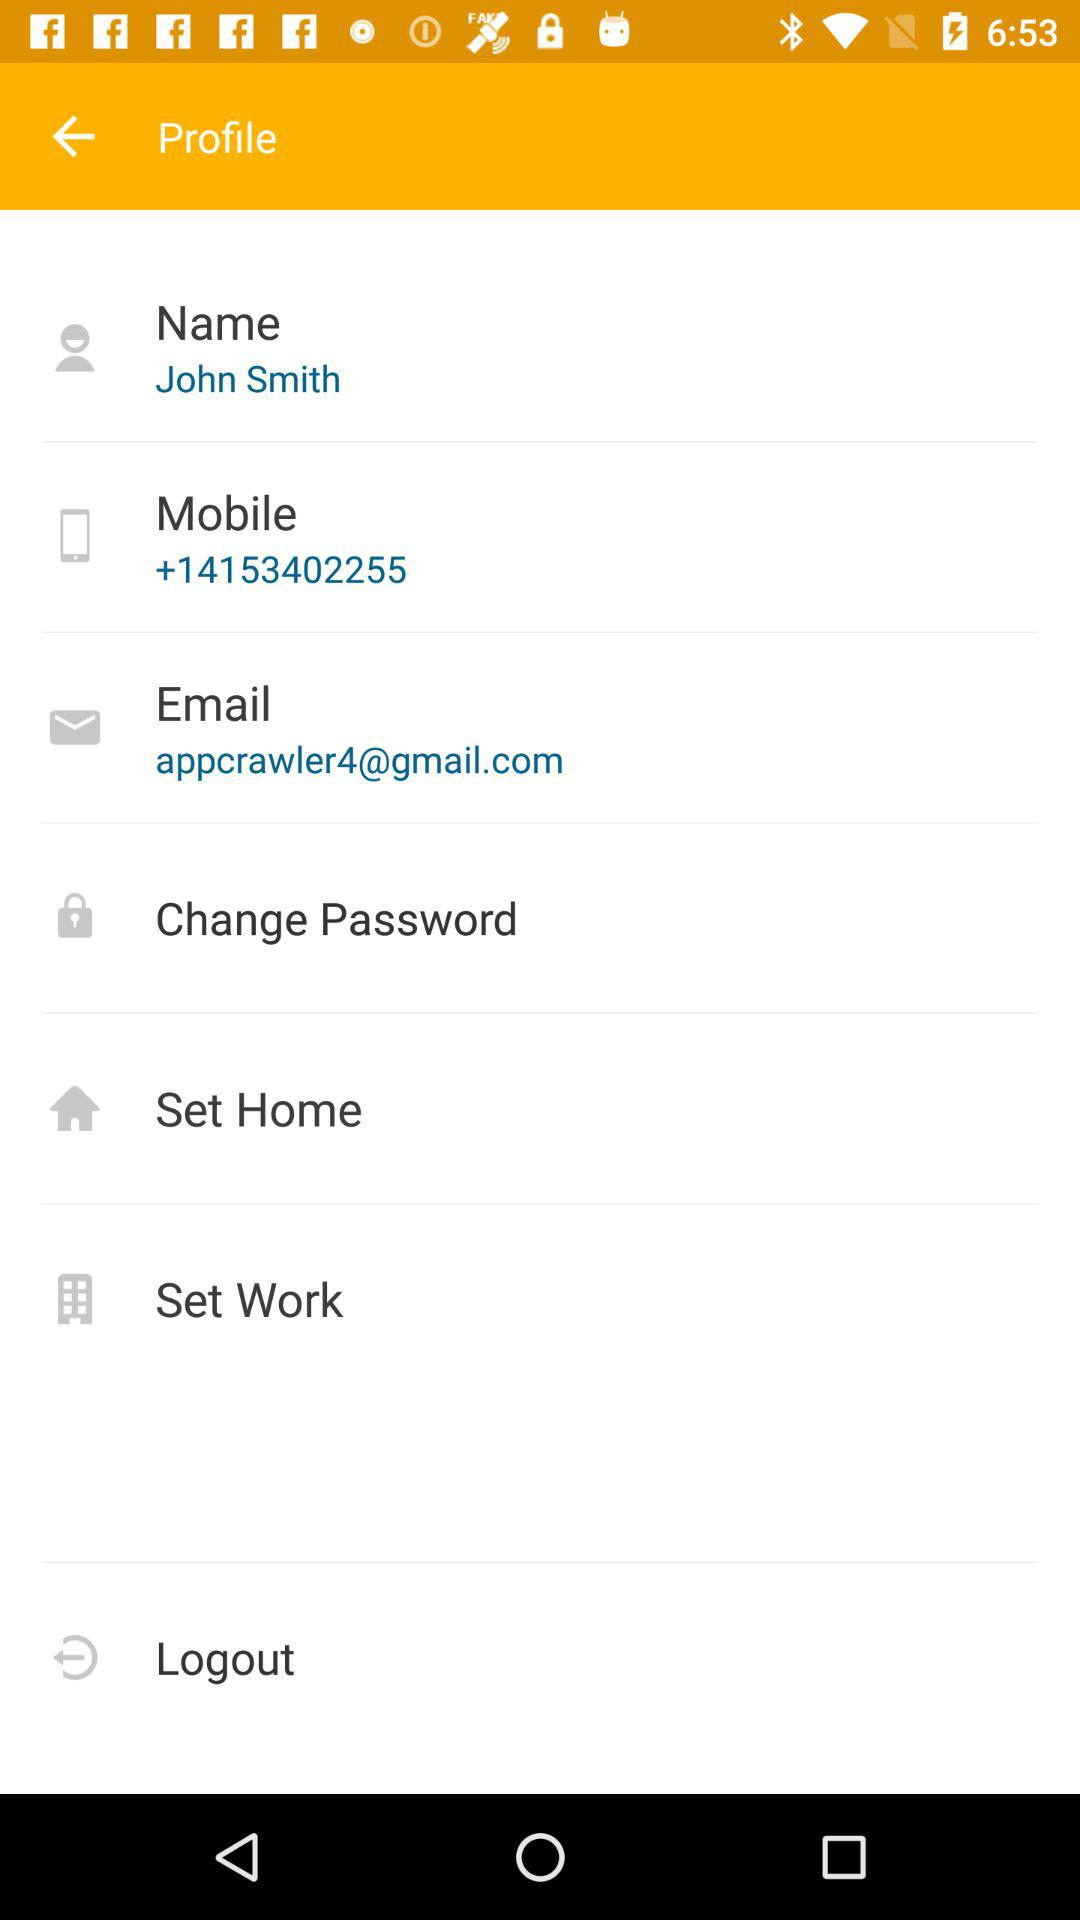What is the mobile number? The mobile number is +14153402255. 